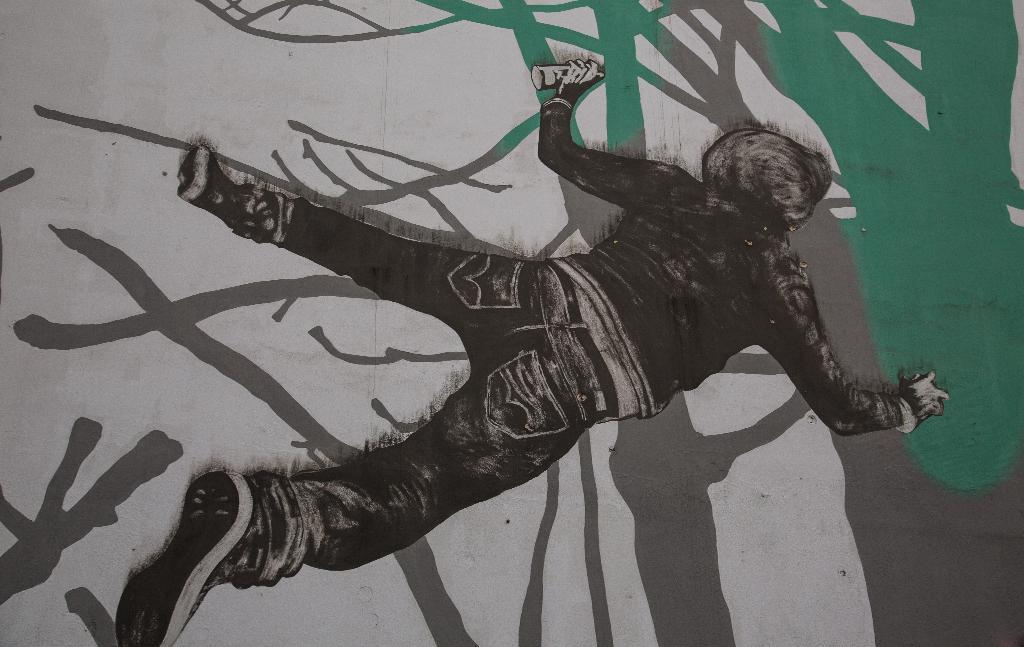Can you describe this image briefly? In the image we can see the image is a painting of person who is lying on the floor. The person is wearing jacket and he is holding the spray bottle in his hand. 